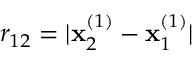Convert formula to latex. <formula><loc_0><loc_0><loc_500><loc_500>r _ { 1 2 } = | x _ { 2 } ^ { ( 1 ) } - x _ { 1 } ^ { ( 1 ) } |</formula> 